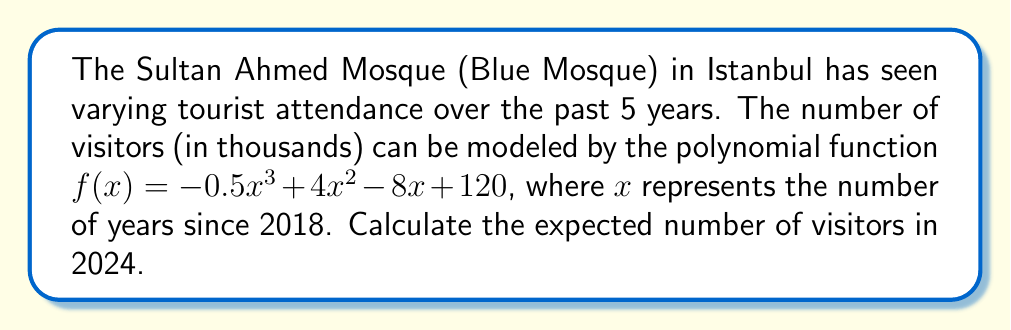Provide a solution to this math problem. To solve this problem, we'll follow these steps:

1) First, we need to determine what value of $x$ corresponds to the year 2024.
   Since $x = 0$ represents 2018, $x = 6$ will represent 2024 (6 years after 2018).

2) Now, we need to evaluate the function $f(x)$ at $x = 6$:

   $f(6) = -0.5(6)^3 + 4(6)^2 - 8(6) + 120$

3) Let's calculate each term:
   $-0.5(6)^3 = -0.5(216) = -108$
   $4(6)^2 = 4(36) = 144$
   $-8(6) = -48$
   $120$ remains as is

4) Now, let's add these terms:

   $f(6) = -108 + 144 - 48 + 120 = 108$

5) Remember that the function gives the number of visitors in thousands.

Therefore, the expected number of visitors in 2024 is 108,000.
Answer: 108,000 visitors 